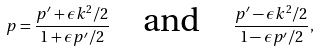<formula> <loc_0><loc_0><loc_500><loc_500>p = \frac { p { ^ { \prime } } + \epsilon k ^ { 2 } / 2 } { 1 + \epsilon p { ^ { \prime } } / 2 } \quad \text {and} \quad \frac { p { ^ { \prime } } - \epsilon k ^ { 2 } / 2 } { 1 - \epsilon p { ^ { \prime } } / 2 } ,</formula> 